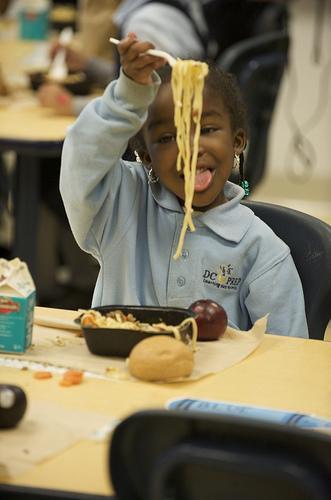How many apples can be seen?
Give a very brief answer. 1. 